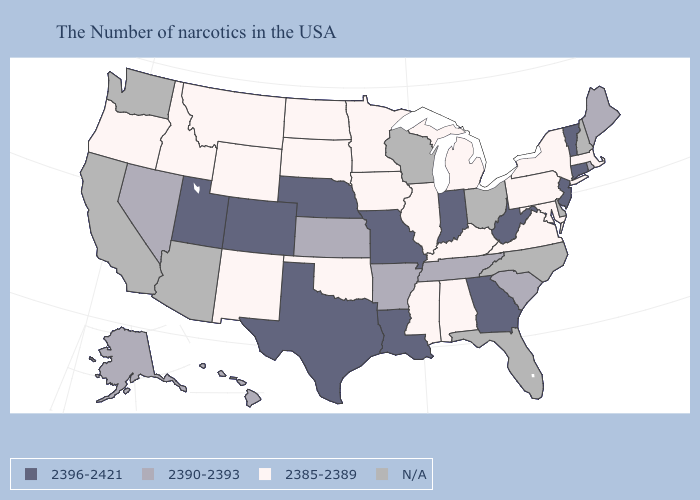Does New York have the lowest value in the USA?
Quick response, please. Yes. Is the legend a continuous bar?
Give a very brief answer. No. Among the states that border Connecticut , does Massachusetts have the highest value?
Concise answer only. No. Among the states that border Ohio , does Indiana have the lowest value?
Short answer required. No. Does New York have the lowest value in the Northeast?
Give a very brief answer. Yes. Does the map have missing data?
Quick response, please. Yes. What is the value of Florida?
Be succinct. N/A. Does New Jersey have the highest value in the Northeast?
Give a very brief answer. Yes. Which states have the lowest value in the USA?
Concise answer only. Massachusetts, New York, Maryland, Pennsylvania, Virginia, Michigan, Kentucky, Alabama, Illinois, Mississippi, Minnesota, Iowa, Oklahoma, South Dakota, North Dakota, Wyoming, New Mexico, Montana, Idaho, Oregon. What is the value of Washington?
Answer briefly. N/A. Does Texas have the highest value in the USA?
Write a very short answer. Yes. Name the states that have a value in the range 2385-2389?
Quick response, please. Massachusetts, New York, Maryland, Pennsylvania, Virginia, Michigan, Kentucky, Alabama, Illinois, Mississippi, Minnesota, Iowa, Oklahoma, South Dakota, North Dakota, Wyoming, New Mexico, Montana, Idaho, Oregon. 